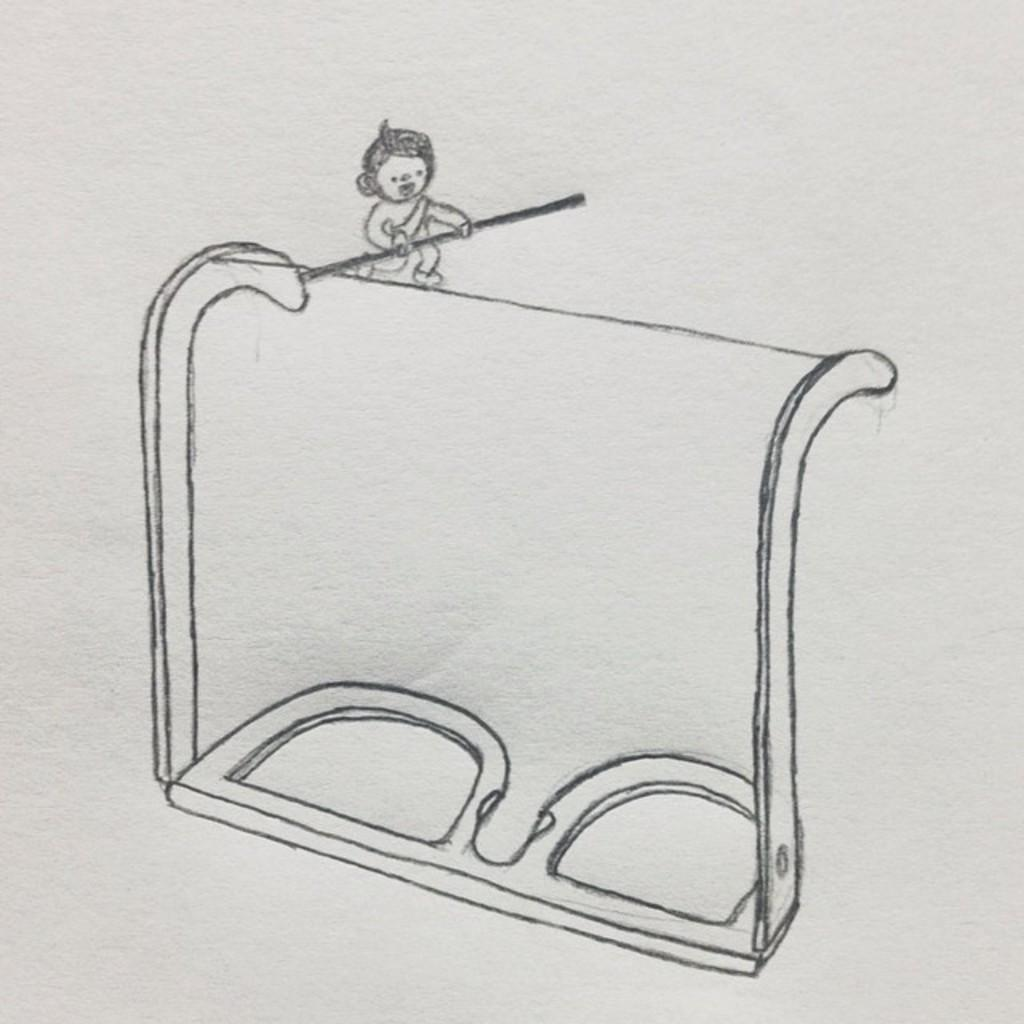What is depicted in the drawing in the image? There is a drawing of a pair of specs in the image. What is unique about the specs in the drawing? There is a thread between the legs of the specs in the drawing. What is the child in the drawing doing? The child is walking and holding a stick in the drawing. What color is the background of the image? The background of the image is white. How many people are attending the feast in the image? There is no feast depicted in the image; it features a drawing of a pair of specs, a child walking, and a white background. What is the name of the daughter in the image? There is no daughter present in the image. 